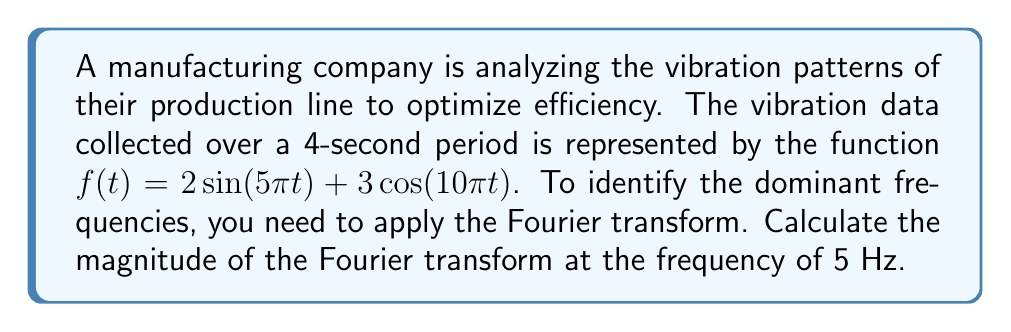Provide a solution to this math problem. To solve this problem, we'll follow these steps:

1) The Fourier transform of a function $f(t)$ is given by:

   $$F(\omega) = \int_{-\infty}^{\infty} f(t) e^{-i\omega t} dt$$

2) In our case, $f(t) = 2\sin(5\pi t) + 3\cos(10\pi t)$

3) We need to calculate $|F(\omega)|$ at $\omega = 2\pi f = 2\pi(5) = 10\pi$

4) Using Euler's formula, we can express sine and cosine in terms of complex exponentials:

   $\sin(5\pi t) = \frac{e^{i5\pi t} - e^{-i5\pi t}}{2i}$
   $\cos(10\pi t) = \frac{e^{i10\pi t} + e^{-i10\pi t}}{2}$

5) Substituting these into our function:

   $f(t) = 2(\frac{e^{i5\pi t} - e^{-i5\pi t}}{2i}) + 3(\frac{e^{i10\pi t} + e^{-i10\pi t}}{2})$

6) Simplifying:

   $f(t) = \frac{e^{i5\pi t} - e^{-i5\pi t}}{i} + \frac{3}{2}(e^{i10\pi t} + e^{-i10\pi t})$

7) Now, let's apply the Fourier transform. The transform of $e^{i\alpha t}$ is $2\pi\delta(\omega - \alpha)$, where $\delta$ is the Dirac delta function.

8) Therefore:

   $F(\omega) = \frac{2\pi}{i}[\delta(\omega - 5\pi) - \delta(\omega + 5\pi)] + \frac{3\pi}{2}[\delta(\omega - 10\pi) + \delta(\omega + 10\pi)]$

9) At $\omega = 10\pi$, only the last term contributes:

   $F(10\pi) = \frac{3\pi}{2}$

10) The magnitude is therefore:

    $|F(10\pi)| = |\frac{3\pi}{2}| = \frac{3\pi}{2}$
Answer: $\frac{3\pi}{2} \approx 4.71$ 